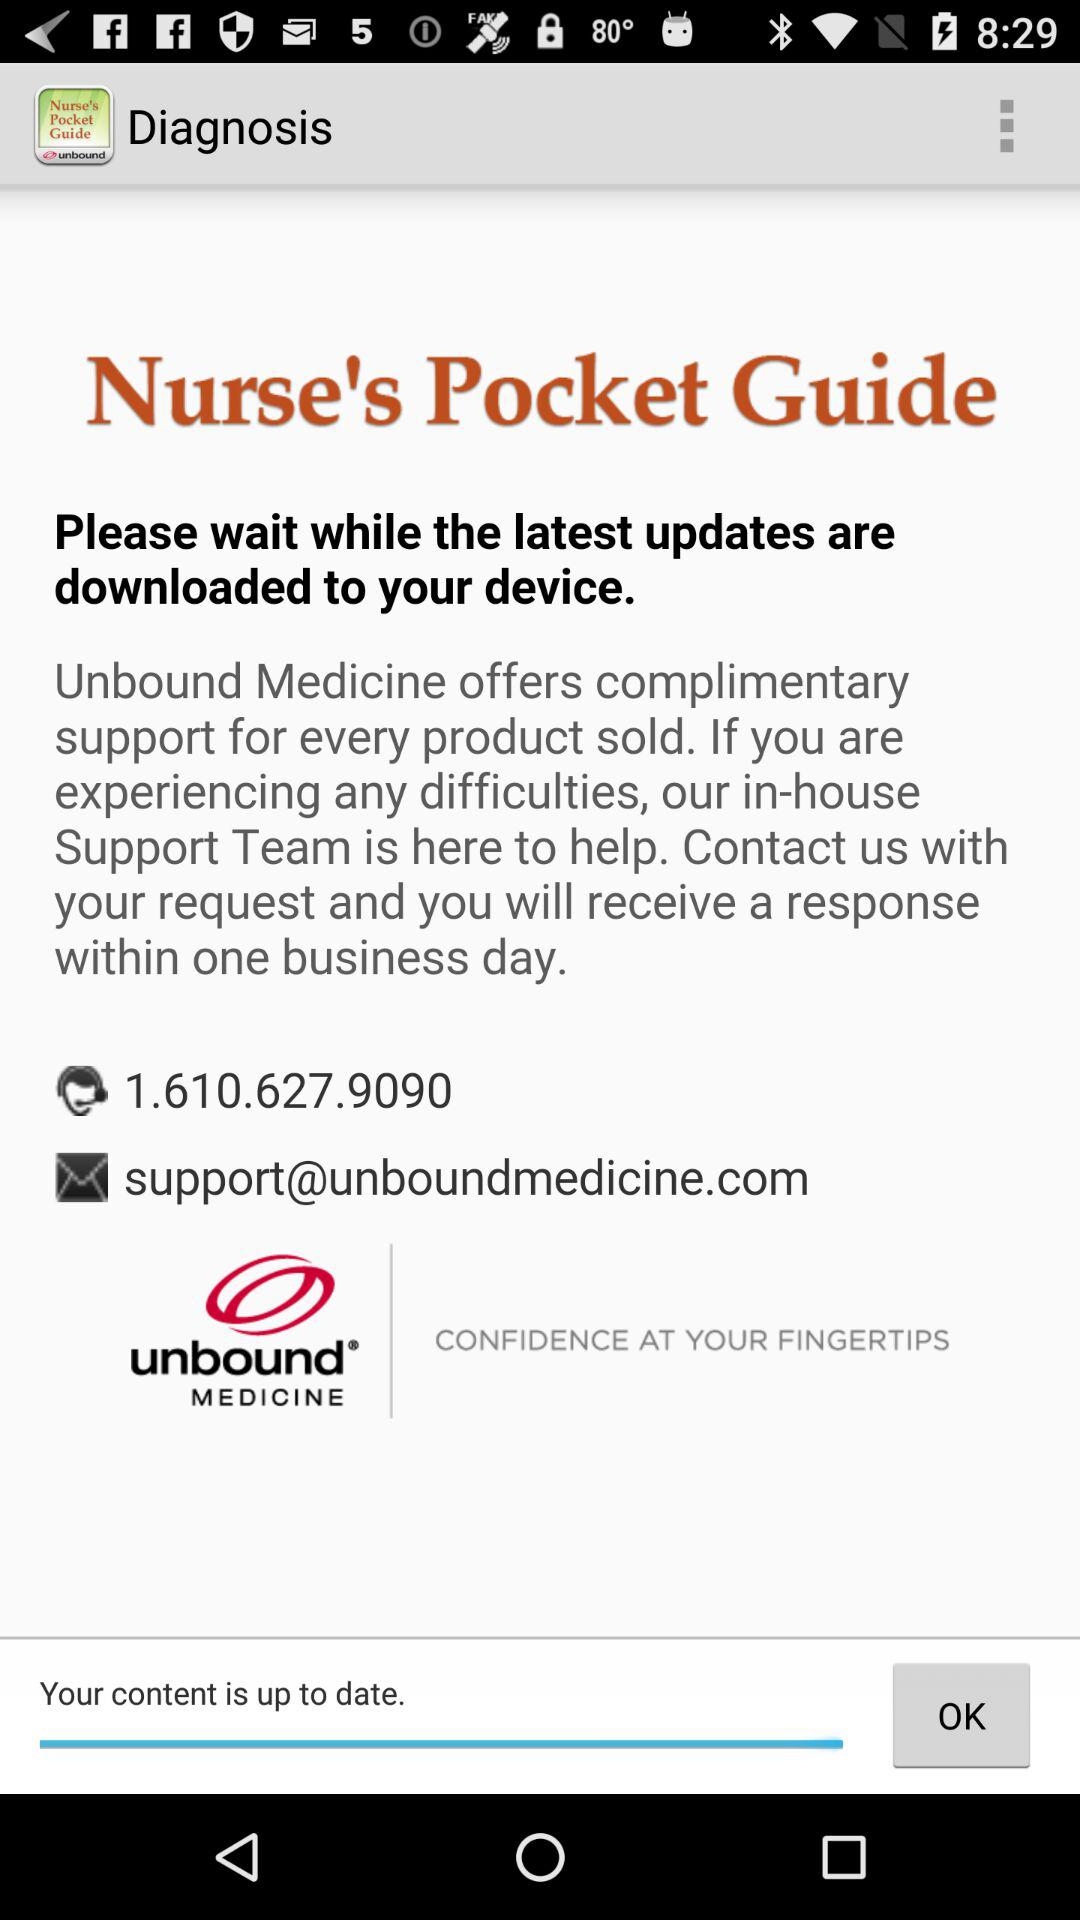What is the phone number? The phone number is 1.610.627.9090. 